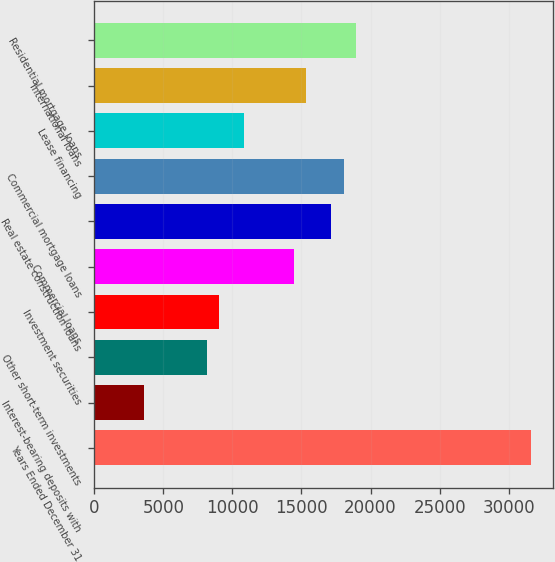Convert chart. <chart><loc_0><loc_0><loc_500><loc_500><bar_chart><fcel>Years Ended December 31<fcel>Interest-bearing deposits with<fcel>Other short-term investments<fcel>Investment securities<fcel>Commercial loans<fcel>Real estate construction loans<fcel>Commercial mortgage loans<fcel>Lease financing<fcel>International loans<fcel>Residential mortgage loans<nl><fcel>31622.3<fcel>3614.08<fcel>8131.53<fcel>9035.02<fcel>14456<fcel>17166.4<fcel>18069.9<fcel>10842<fcel>15359.5<fcel>18973.4<nl></chart> 